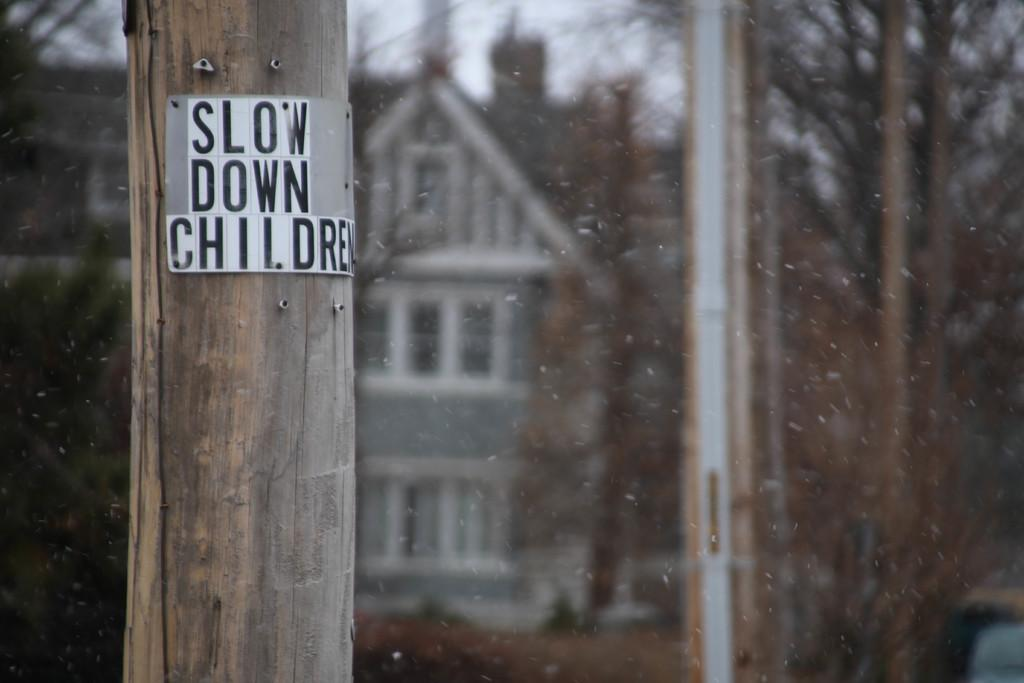What is the main object in the foreground of the image? There is a wooden pole with a board on it in the image. What can be seen in the background of the image? There is a building, trees, and some objects in the background of the image. Can you describe the quality of the image? The image is blurry. What type of oil is being used to clean the plate in the image? There is no plate or oil present in the image. What level of detail can be seen on the board in the image? The image is blurry, so it is difficult to discern the level of detail on the board. 